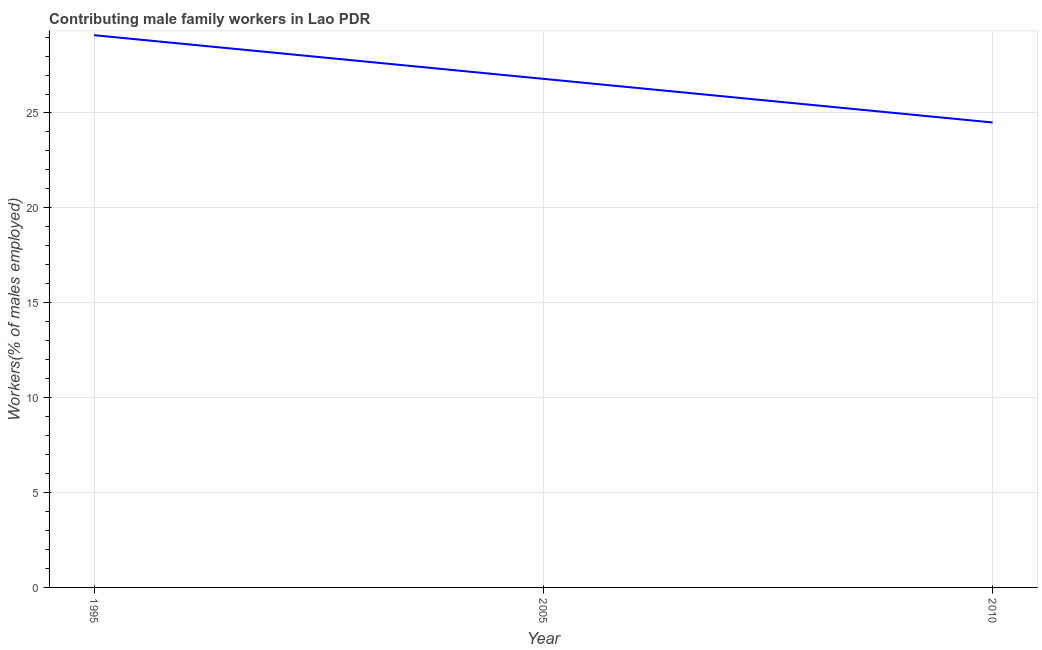What is the contributing male family workers in 2005?
Your response must be concise. 26.8. Across all years, what is the maximum contributing male family workers?
Your answer should be very brief. 29.1. Across all years, what is the minimum contributing male family workers?
Offer a very short reply. 24.5. In which year was the contributing male family workers minimum?
Your response must be concise. 2010. What is the sum of the contributing male family workers?
Provide a short and direct response. 80.4. What is the difference between the contributing male family workers in 1995 and 2005?
Offer a terse response. 2.3. What is the average contributing male family workers per year?
Your answer should be compact. 26.8. What is the median contributing male family workers?
Offer a very short reply. 26.8. In how many years, is the contributing male family workers greater than 5 %?
Provide a short and direct response. 3. What is the ratio of the contributing male family workers in 1995 to that in 2005?
Your response must be concise. 1.09. Is the contributing male family workers in 1995 less than that in 2005?
Keep it short and to the point. No. What is the difference between the highest and the second highest contributing male family workers?
Your answer should be very brief. 2.3. Is the sum of the contributing male family workers in 2005 and 2010 greater than the maximum contributing male family workers across all years?
Offer a very short reply. Yes. What is the difference between the highest and the lowest contributing male family workers?
Provide a short and direct response. 4.6. In how many years, is the contributing male family workers greater than the average contributing male family workers taken over all years?
Ensure brevity in your answer.  1. How many years are there in the graph?
Ensure brevity in your answer.  3. Are the values on the major ticks of Y-axis written in scientific E-notation?
Make the answer very short. No. Does the graph contain any zero values?
Offer a very short reply. No. What is the title of the graph?
Provide a succinct answer. Contributing male family workers in Lao PDR. What is the label or title of the Y-axis?
Offer a very short reply. Workers(% of males employed). What is the Workers(% of males employed) in 1995?
Your response must be concise. 29.1. What is the Workers(% of males employed) of 2005?
Make the answer very short. 26.8. What is the ratio of the Workers(% of males employed) in 1995 to that in 2005?
Provide a short and direct response. 1.09. What is the ratio of the Workers(% of males employed) in 1995 to that in 2010?
Provide a succinct answer. 1.19. What is the ratio of the Workers(% of males employed) in 2005 to that in 2010?
Keep it short and to the point. 1.09. 